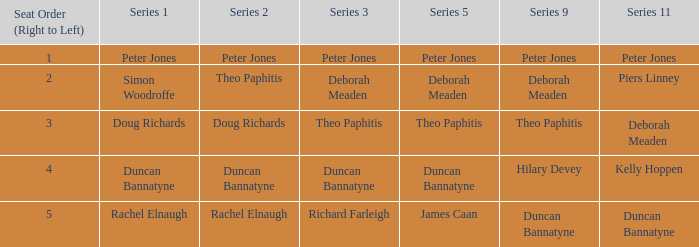Which series 1 includes a series 11 with peter jones? Peter Jones. 